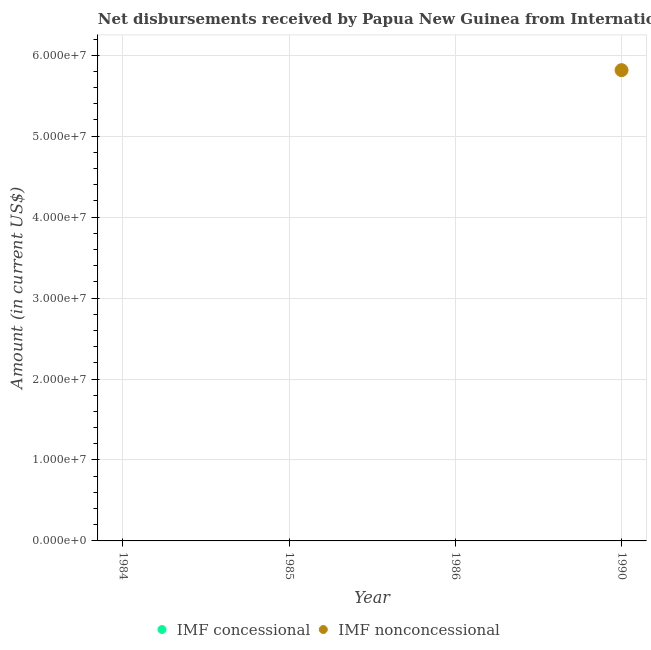How many different coloured dotlines are there?
Ensure brevity in your answer.  1. Is the number of dotlines equal to the number of legend labels?
Offer a very short reply. No. What is the net concessional disbursements from imf in 1985?
Keep it short and to the point. 0. Across all years, what is the maximum net non concessional disbursements from imf?
Make the answer very short. 5.82e+07. Across all years, what is the minimum net concessional disbursements from imf?
Keep it short and to the point. 0. What is the total net non concessional disbursements from imf in the graph?
Keep it short and to the point. 5.82e+07. What is the difference between the net non concessional disbursements from imf in 1990 and the net concessional disbursements from imf in 1984?
Ensure brevity in your answer.  5.82e+07. What is the average net non concessional disbursements from imf per year?
Offer a very short reply. 1.45e+07. What is the difference between the highest and the lowest net non concessional disbursements from imf?
Ensure brevity in your answer.  5.82e+07. In how many years, is the net concessional disbursements from imf greater than the average net concessional disbursements from imf taken over all years?
Keep it short and to the point. 0. Does the net concessional disbursements from imf monotonically increase over the years?
Give a very brief answer. No. Is the net non concessional disbursements from imf strictly greater than the net concessional disbursements from imf over the years?
Your answer should be very brief. No. Is the net concessional disbursements from imf strictly less than the net non concessional disbursements from imf over the years?
Provide a short and direct response. No. Are the values on the major ticks of Y-axis written in scientific E-notation?
Provide a short and direct response. Yes. Where does the legend appear in the graph?
Give a very brief answer. Bottom center. How many legend labels are there?
Offer a very short reply. 2. How are the legend labels stacked?
Offer a terse response. Horizontal. What is the title of the graph?
Provide a succinct answer. Net disbursements received by Papua New Guinea from International Monetary Fund. What is the label or title of the X-axis?
Provide a succinct answer. Year. What is the label or title of the Y-axis?
Offer a very short reply. Amount (in current US$). What is the Amount (in current US$) in IMF nonconcessional in 1984?
Keep it short and to the point. 0. What is the Amount (in current US$) of IMF concessional in 1985?
Offer a terse response. 0. What is the Amount (in current US$) in IMF nonconcessional in 1986?
Your answer should be compact. 0. What is the Amount (in current US$) in IMF concessional in 1990?
Ensure brevity in your answer.  0. What is the Amount (in current US$) of IMF nonconcessional in 1990?
Provide a short and direct response. 5.82e+07. Across all years, what is the maximum Amount (in current US$) in IMF nonconcessional?
Your answer should be very brief. 5.82e+07. Across all years, what is the minimum Amount (in current US$) in IMF nonconcessional?
Keep it short and to the point. 0. What is the total Amount (in current US$) in IMF nonconcessional in the graph?
Offer a very short reply. 5.82e+07. What is the average Amount (in current US$) of IMF nonconcessional per year?
Your response must be concise. 1.45e+07. What is the difference between the highest and the lowest Amount (in current US$) in IMF nonconcessional?
Offer a terse response. 5.82e+07. 